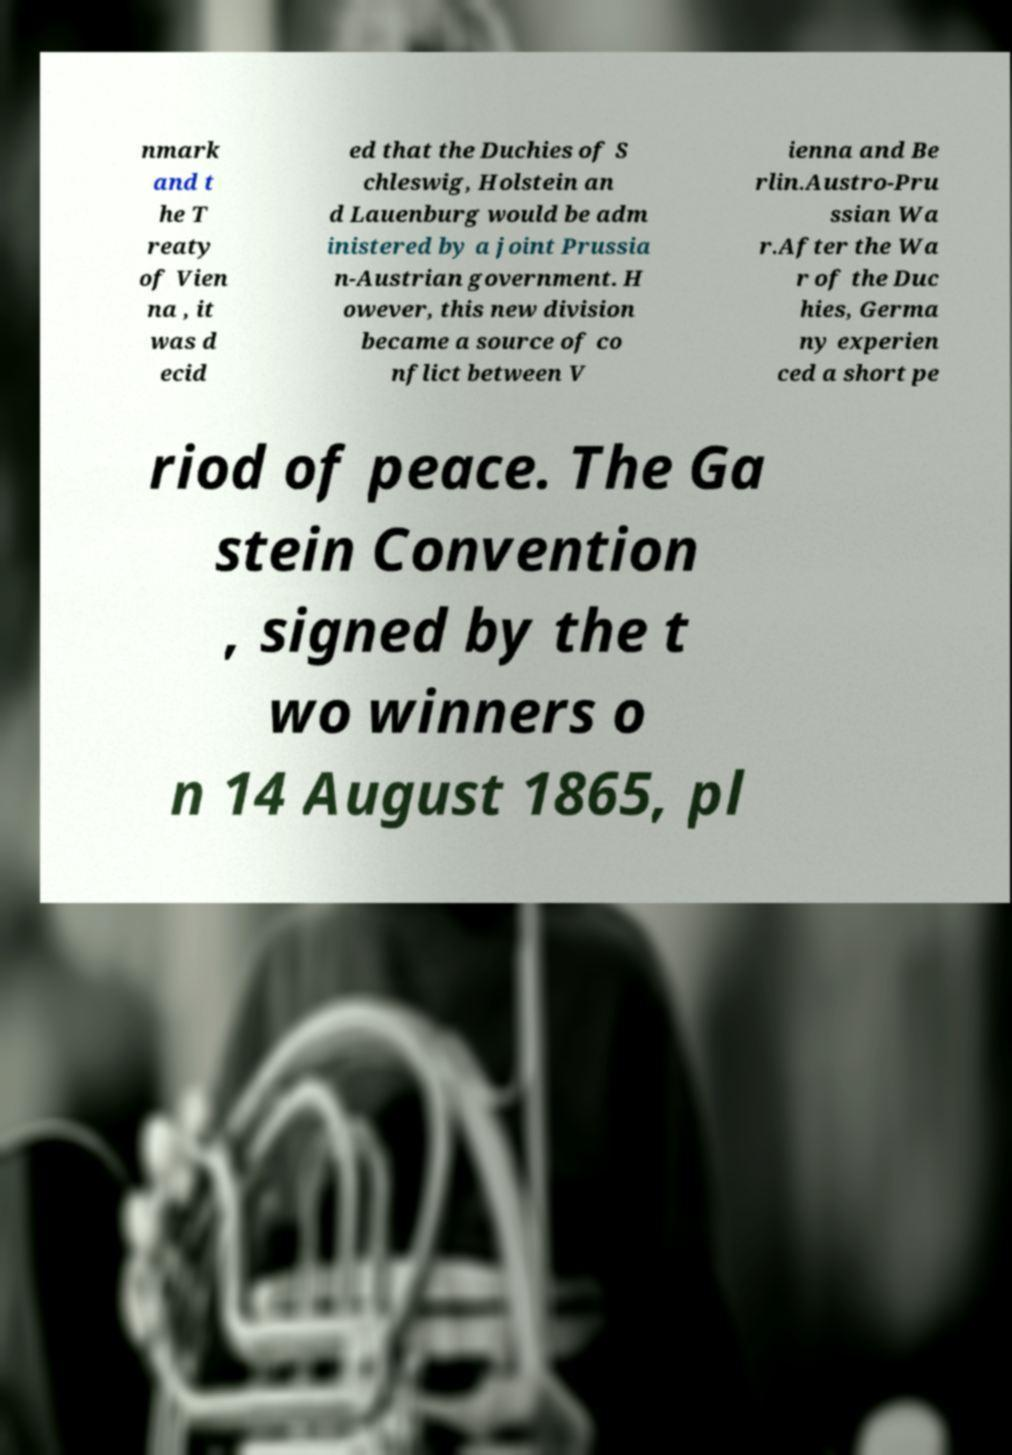Please identify and transcribe the text found in this image. nmark and t he T reaty of Vien na , it was d ecid ed that the Duchies of S chleswig, Holstein an d Lauenburg would be adm inistered by a joint Prussia n-Austrian government. H owever, this new division became a source of co nflict between V ienna and Be rlin.Austro-Pru ssian Wa r.After the Wa r of the Duc hies, Germa ny experien ced a short pe riod of peace. The Ga stein Convention , signed by the t wo winners o n 14 August 1865, pl 